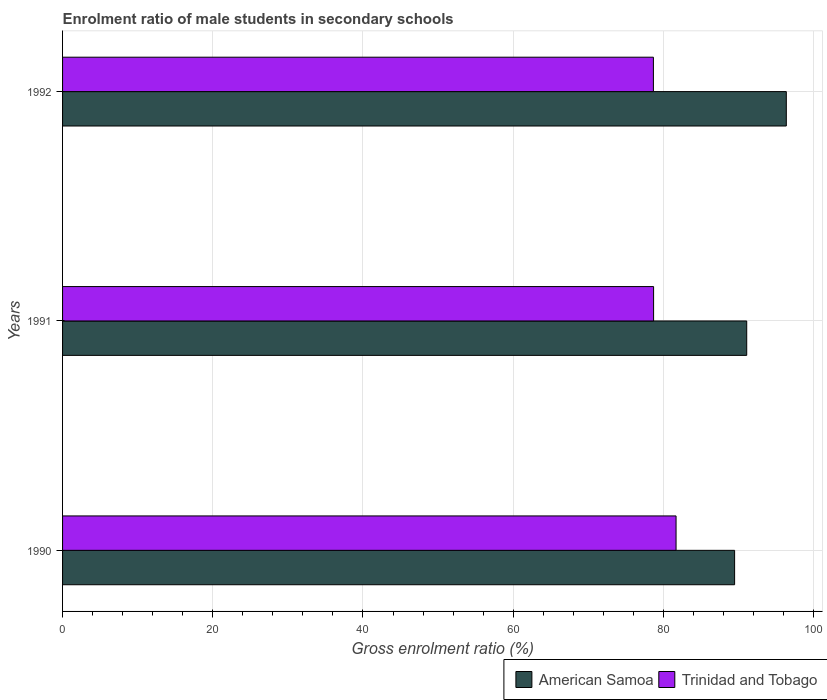Are the number of bars on each tick of the Y-axis equal?
Keep it short and to the point. Yes. How many bars are there on the 1st tick from the top?
Provide a succinct answer. 2. How many bars are there on the 3rd tick from the bottom?
Your response must be concise. 2. What is the enrolment ratio of male students in secondary schools in American Samoa in 1990?
Your answer should be very brief. 89.48. Across all years, what is the maximum enrolment ratio of male students in secondary schools in Trinidad and Tobago?
Your answer should be very brief. 81.69. Across all years, what is the minimum enrolment ratio of male students in secondary schools in Trinidad and Tobago?
Provide a succinct answer. 78.67. What is the total enrolment ratio of male students in secondary schools in American Samoa in the graph?
Your response must be concise. 276.95. What is the difference between the enrolment ratio of male students in secondary schools in Trinidad and Tobago in 1990 and that in 1991?
Ensure brevity in your answer.  2.99. What is the difference between the enrolment ratio of male students in secondary schools in Trinidad and Tobago in 1990 and the enrolment ratio of male students in secondary schools in American Samoa in 1991?
Offer a terse response. -9.41. What is the average enrolment ratio of male students in secondary schools in American Samoa per year?
Make the answer very short. 92.32. In the year 1992, what is the difference between the enrolment ratio of male students in secondary schools in Trinidad and Tobago and enrolment ratio of male students in secondary schools in American Samoa?
Provide a short and direct response. -17.7. In how many years, is the enrolment ratio of male students in secondary schools in Trinidad and Tobago greater than 32 %?
Offer a very short reply. 3. What is the ratio of the enrolment ratio of male students in secondary schools in Trinidad and Tobago in 1991 to that in 1992?
Give a very brief answer. 1. What is the difference between the highest and the second highest enrolment ratio of male students in secondary schools in Trinidad and Tobago?
Give a very brief answer. 2.99. What is the difference between the highest and the lowest enrolment ratio of male students in secondary schools in American Samoa?
Your response must be concise. 6.88. In how many years, is the enrolment ratio of male students in secondary schools in Trinidad and Tobago greater than the average enrolment ratio of male students in secondary schools in Trinidad and Tobago taken over all years?
Give a very brief answer. 1. Is the sum of the enrolment ratio of male students in secondary schools in American Samoa in 1990 and 1992 greater than the maximum enrolment ratio of male students in secondary schools in Trinidad and Tobago across all years?
Offer a terse response. Yes. What does the 1st bar from the top in 1990 represents?
Make the answer very short. Trinidad and Tobago. What does the 2nd bar from the bottom in 1992 represents?
Offer a terse response. Trinidad and Tobago. Are the values on the major ticks of X-axis written in scientific E-notation?
Your response must be concise. No. Where does the legend appear in the graph?
Keep it short and to the point. Bottom right. How many legend labels are there?
Keep it short and to the point. 2. What is the title of the graph?
Your response must be concise. Enrolment ratio of male students in secondary schools. What is the label or title of the Y-axis?
Provide a succinct answer. Years. What is the Gross enrolment ratio (%) of American Samoa in 1990?
Offer a very short reply. 89.48. What is the Gross enrolment ratio (%) in Trinidad and Tobago in 1990?
Offer a very short reply. 81.69. What is the Gross enrolment ratio (%) of American Samoa in 1991?
Give a very brief answer. 91.1. What is the Gross enrolment ratio (%) of Trinidad and Tobago in 1991?
Your answer should be compact. 78.7. What is the Gross enrolment ratio (%) in American Samoa in 1992?
Your answer should be compact. 96.37. What is the Gross enrolment ratio (%) in Trinidad and Tobago in 1992?
Your answer should be very brief. 78.67. Across all years, what is the maximum Gross enrolment ratio (%) in American Samoa?
Your response must be concise. 96.37. Across all years, what is the maximum Gross enrolment ratio (%) of Trinidad and Tobago?
Give a very brief answer. 81.69. Across all years, what is the minimum Gross enrolment ratio (%) of American Samoa?
Offer a terse response. 89.48. Across all years, what is the minimum Gross enrolment ratio (%) of Trinidad and Tobago?
Provide a succinct answer. 78.67. What is the total Gross enrolment ratio (%) of American Samoa in the graph?
Make the answer very short. 276.95. What is the total Gross enrolment ratio (%) in Trinidad and Tobago in the graph?
Offer a terse response. 239.06. What is the difference between the Gross enrolment ratio (%) of American Samoa in 1990 and that in 1991?
Your response must be concise. -1.61. What is the difference between the Gross enrolment ratio (%) in Trinidad and Tobago in 1990 and that in 1991?
Your answer should be very brief. 2.99. What is the difference between the Gross enrolment ratio (%) in American Samoa in 1990 and that in 1992?
Provide a succinct answer. -6.88. What is the difference between the Gross enrolment ratio (%) in Trinidad and Tobago in 1990 and that in 1992?
Keep it short and to the point. 3.02. What is the difference between the Gross enrolment ratio (%) in American Samoa in 1991 and that in 1992?
Provide a short and direct response. -5.27. What is the difference between the Gross enrolment ratio (%) of Trinidad and Tobago in 1991 and that in 1992?
Make the answer very short. 0.03. What is the difference between the Gross enrolment ratio (%) in American Samoa in 1990 and the Gross enrolment ratio (%) in Trinidad and Tobago in 1991?
Provide a short and direct response. 10.79. What is the difference between the Gross enrolment ratio (%) of American Samoa in 1990 and the Gross enrolment ratio (%) of Trinidad and Tobago in 1992?
Your response must be concise. 10.81. What is the difference between the Gross enrolment ratio (%) of American Samoa in 1991 and the Gross enrolment ratio (%) of Trinidad and Tobago in 1992?
Ensure brevity in your answer.  12.43. What is the average Gross enrolment ratio (%) in American Samoa per year?
Keep it short and to the point. 92.32. What is the average Gross enrolment ratio (%) in Trinidad and Tobago per year?
Ensure brevity in your answer.  79.69. In the year 1990, what is the difference between the Gross enrolment ratio (%) of American Samoa and Gross enrolment ratio (%) of Trinidad and Tobago?
Your answer should be compact. 7.8. In the year 1991, what is the difference between the Gross enrolment ratio (%) of American Samoa and Gross enrolment ratio (%) of Trinidad and Tobago?
Provide a short and direct response. 12.4. In the year 1992, what is the difference between the Gross enrolment ratio (%) in American Samoa and Gross enrolment ratio (%) in Trinidad and Tobago?
Give a very brief answer. 17.7. What is the ratio of the Gross enrolment ratio (%) of American Samoa in 1990 to that in 1991?
Offer a very short reply. 0.98. What is the ratio of the Gross enrolment ratio (%) of Trinidad and Tobago in 1990 to that in 1991?
Your response must be concise. 1.04. What is the ratio of the Gross enrolment ratio (%) in Trinidad and Tobago in 1990 to that in 1992?
Your response must be concise. 1.04. What is the ratio of the Gross enrolment ratio (%) in American Samoa in 1991 to that in 1992?
Make the answer very short. 0.95. What is the difference between the highest and the second highest Gross enrolment ratio (%) in American Samoa?
Offer a very short reply. 5.27. What is the difference between the highest and the second highest Gross enrolment ratio (%) in Trinidad and Tobago?
Your answer should be compact. 2.99. What is the difference between the highest and the lowest Gross enrolment ratio (%) of American Samoa?
Your answer should be compact. 6.88. What is the difference between the highest and the lowest Gross enrolment ratio (%) of Trinidad and Tobago?
Your response must be concise. 3.02. 